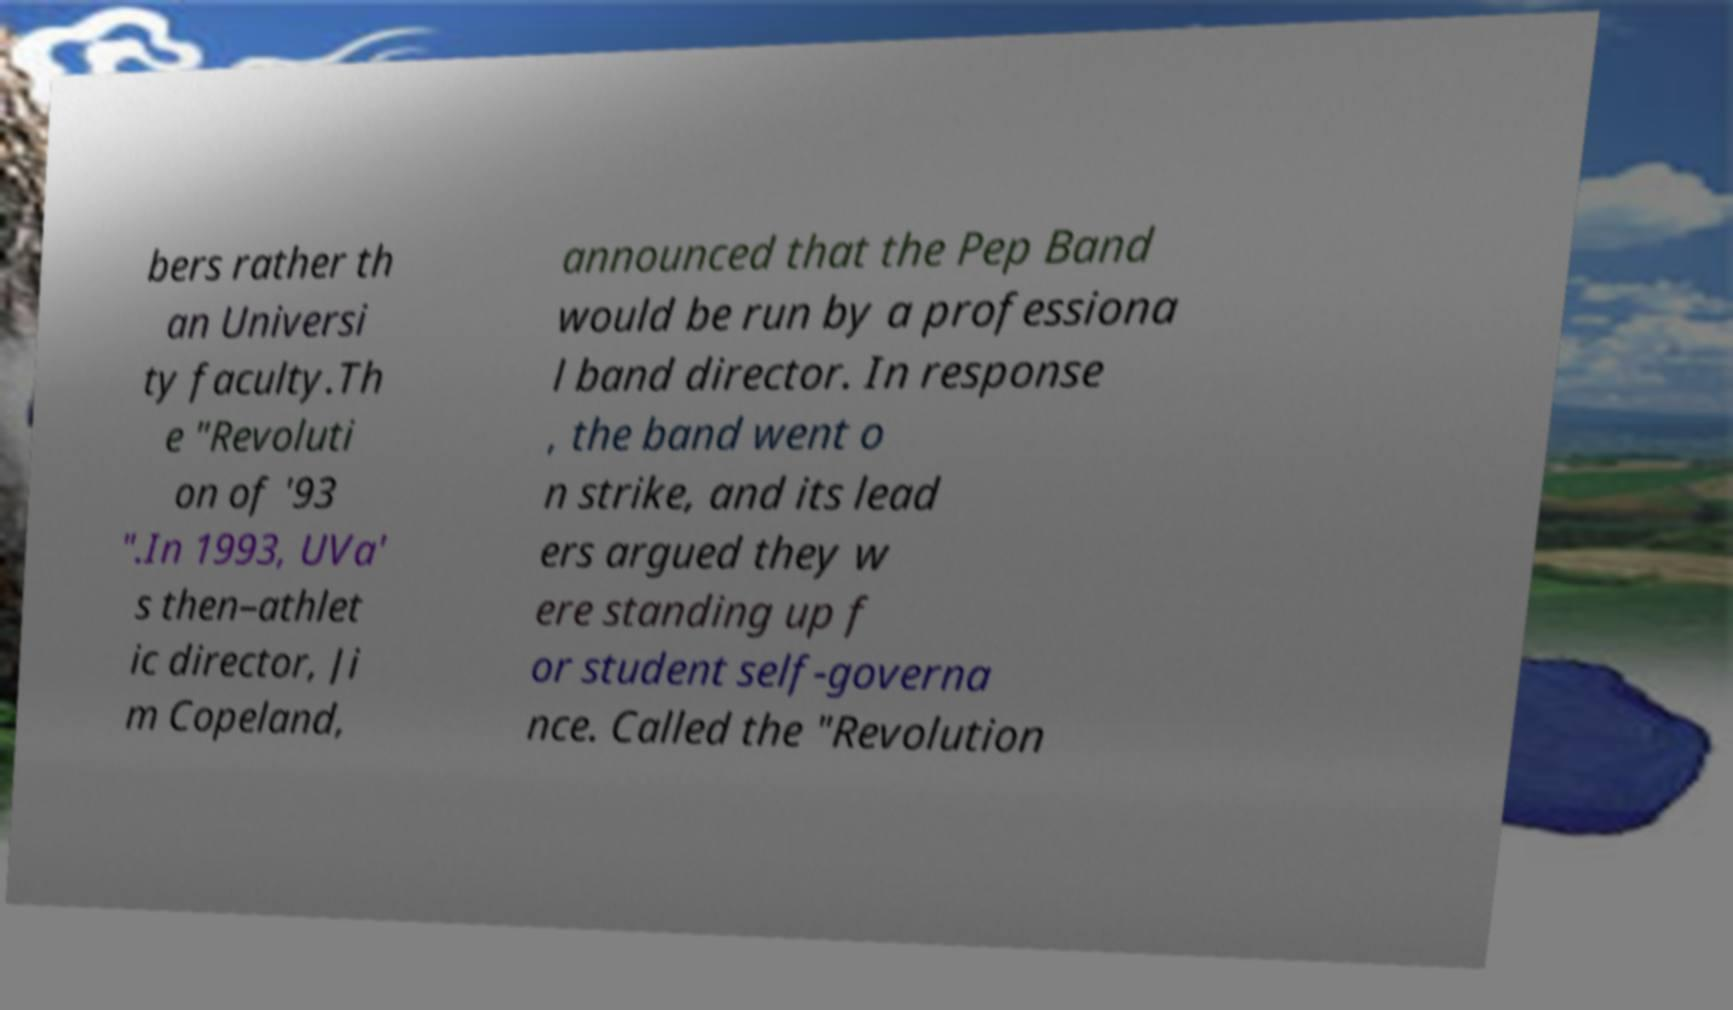I need the written content from this picture converted into text. Can you do that? bers rather th an Universi ty faculty.Th e "Revoluti on of '93 ".In 1993, UVa' s then–athlet ic director, Ji m Copeland, announced that the Pep Band would be run by a professiona l band director. In response , the band went o n strike, and its lead ers argued they w ere standing up f or student self-governa nce. Called the "Revolution 